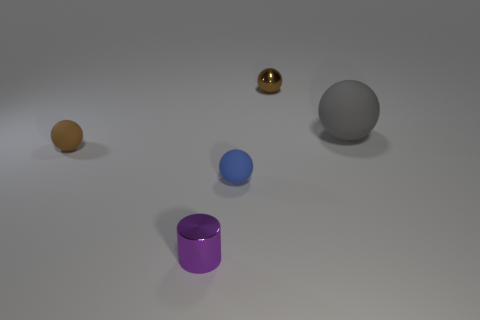Is there an indication of the light source direction based on the shadows in the image? Yes, shadows in the image suggest that the light source is coming from the top left, as indicated by the direction of the shadows casting towards the bottom right of the frame. 